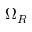Convert formula to latex. <formula><loc_0><loc_0><loc_500><loc_500>\Omega _ { R }</formula> 